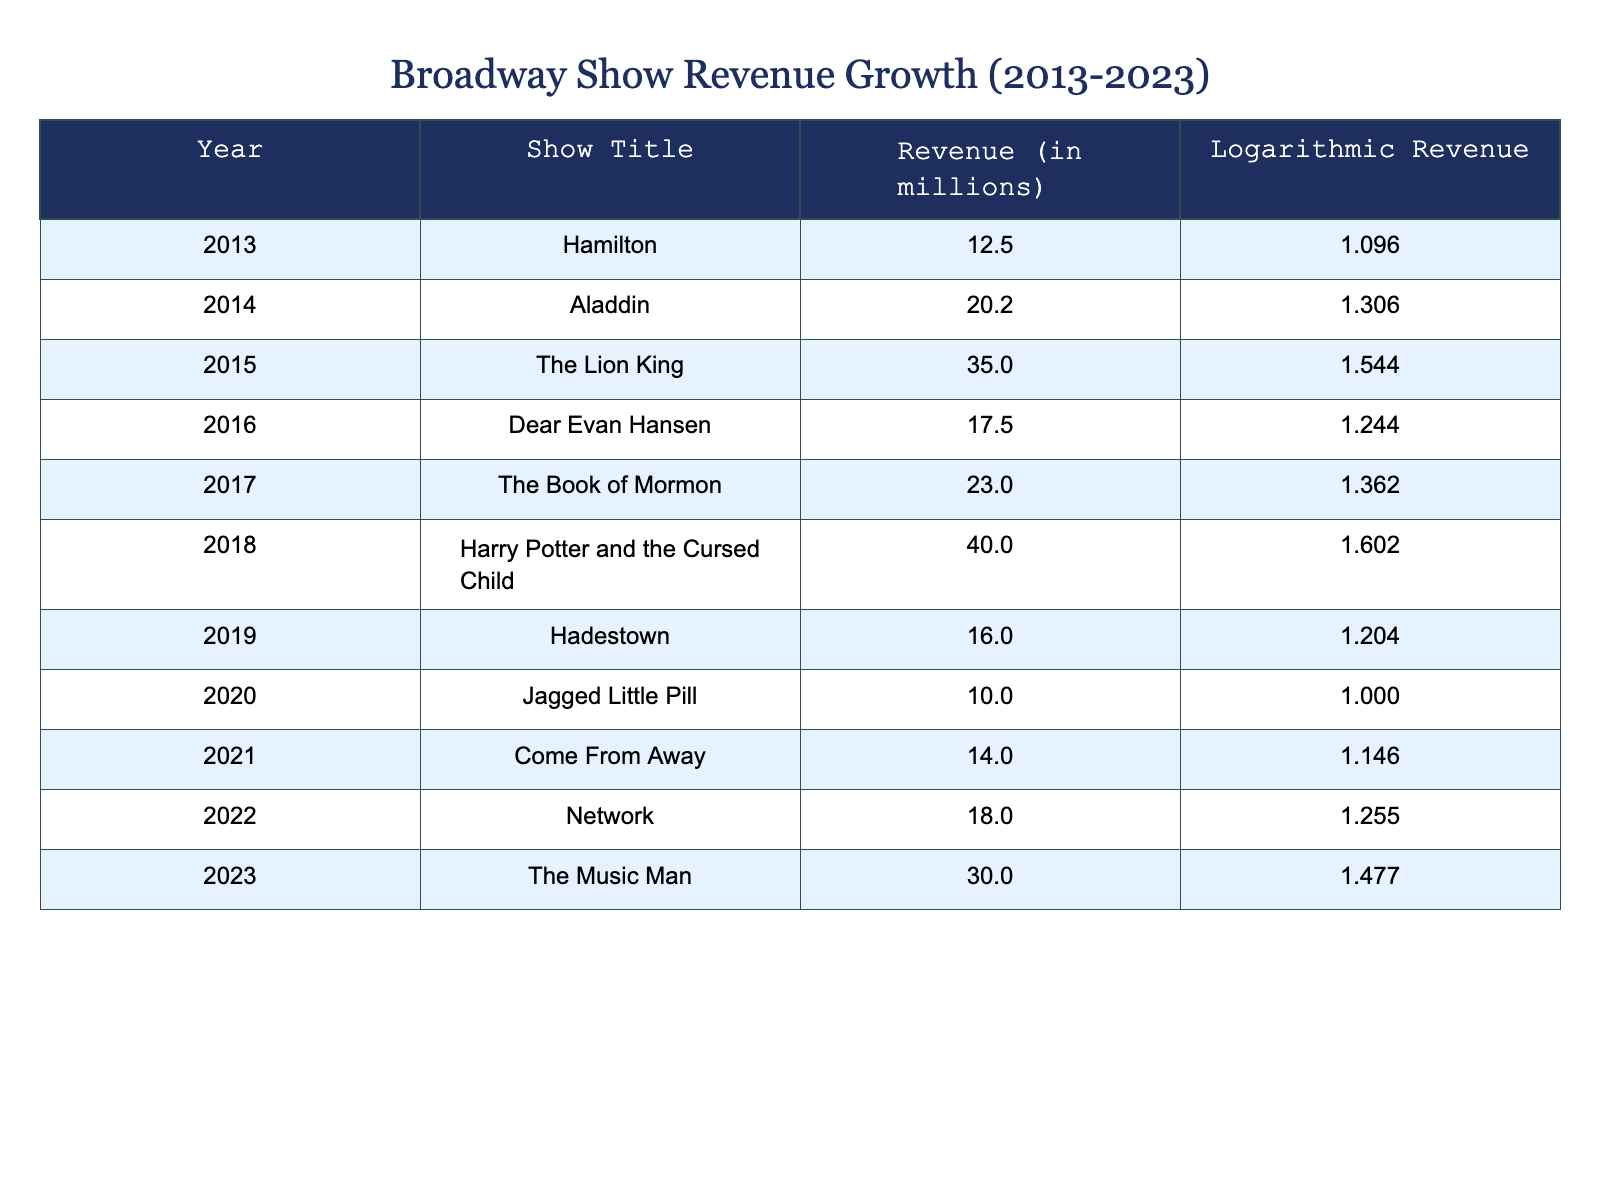What was the highest revenue generated by a show in 2018? The table shows that in 2018, the show "Harry Potter and the Cursed Child" generated the highest revenue of 40.0 million.
Answer: 40.0 million Which show had the lowest revenue in 2020? In 2020, "Jagged Little Pill" had the lowest revenue, which is 10.0 million.
Answer: 10.0 million What is the total revenue from shows between 2013 and 2015? We find the revenue for the years 2013 to 2015: 12.5 (2013) + 20.2 (2014) + 35.0 (2015) = 67.7 million. Thus, the total revenue is 67.7 million.
Answer: 67.7 million Did any show in 2022 generate more revenue than in 2021? In 2021, "Come From Away" generated 14.0 million, whereas in 2022, "Network" generated 18.0 million, which is greater than 14.0 million. Thus, the statement is true.
Answer: Yes What is the percentage increase in revenue from 2019 to 2023? To calculate the percentage increase, we take the revenue in 2023 (30.0 million) and subtract the revenue in 2019 (16.0 million), leading to 30.0 - 16.0 = 14.0 million. Then, (14.0 / 16.0) * 100 = 87.5%. Therefore, the percentage increase in revenue is 87.5%.
Answer: 87.5% 